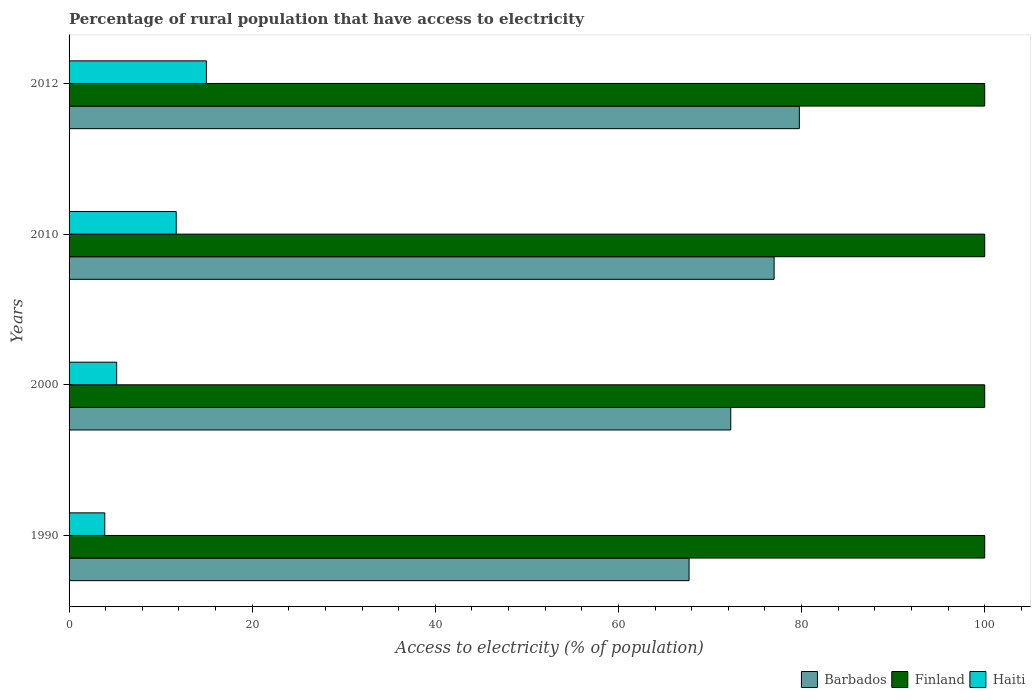How many bars are there on the 4th tick from the top?
Offer a terse response. 3. How many bars are there on the 3rd tick from the bottom?
Offer a very short reply. 3. What is the percentage of rural population that have access to electricity in Finland in 2000?
Offer a very short reply. 100. Across all years, what is the minimum percentage of rural population that have access to electricity in Barbados?
Keep it short and to the point. 67.71. In which year was the percentage of rural population that have access to electricity in Haiti maximum?
Ensure brevity in your answer.  2012. In which year was the percentage of rural population that have access to electricity in Barbados minimum?
Your answer should be compact. 1990. What is the total percentage of rural population that have access to electricity in Finland in the graph?
Your answer should be compact. 400. What is the difference between the percentage of rural population that have access to electricity in Barbados in 1990 and that in 2000?
Offer a very short reply. -4.55. What is the difference between the percentage of rural population that have access to electricity in Finland in 2000 and the percentage of rural population that have access to electricity in Barbados in 2012?
Offer a very short reply. 20.25. What is the average percentage of rural population that have access to electricity in Haiti per year?
Offer a very short reply. 8.95. In the year 2000, what is the difference between the percentage of rural population that have access to electricity in Haiti and percentage of rural population that have access to electricity in Barbados?
Ensure brevity in your answer.  -67.07. What is the ratio of the percentage of rural population that have access to electricity in Haiti in 2000 to that in 2012?
Ensure brevity in your answer.  0.35. What is the difference between the highest and the second highest percentage of rural population that have access to electricity in Haiti?
Provide a succinct answer. 3.3. Is the sum of the percentage of rural population that have access to electricity in Finland in 2000 and 2012 greater than the maximum percentage of rural population that have access to electricity in Haiti across all years?
Give a very brief answer. Yes. What does the 1st bar from the top in 2010 represents?
Provide a succinct answer. Haiti. What does the 3rd bar from the bottom in 2000 represents?
Your response must be concise. Haiti. Is it the case that in every year, the sum of the percentage of rural population that have access to electricity in Haiti and percentage of rural population that have access to electricity in Barbados is greater than the percentage of rural population that have access to electricity in Finland?
Ensure brevity in your answer.  No. How many bars are there?
Make the answer very short. 12. Are all the bars in the graph horizontal?
Ensure brevity in your answer.  Yes. How many years are there in the graph?
Offer a terse response. 4. What is the difference between two consecutive major ticks on the X-axis?
Provide a short and direct response. 20. Are the values on the major ticks of X-axis written in scientific E-notation?
Make the answer very short. No. Does the graph contain any zero values?
Make the answer very short. No. Does the graph contain grids?
Give a very brief answer. No. Where does the legend appear in the graph?
Offer a very short reply. Bottom right. How many legend labels are there?
Provide a succinct answer. 3. How are the legend labels stacked?
Give a very brief answer. Horizontal. What is the title of the graph?
Your answer should be compact. Percentage of rural population that have access to electricity. What is the label or title of the X-axis?
Your answer should be very brief. Access to electricity (% of population). What is the Access to electricity (% of population) in Barbados in 1990?
Your answer should be compact. 67.71. What is the Access to electricity (% of population) of Barbados in 2000?
Your response must be concise. 72.27. What is the Access to electricity (% of population) in Finland in 2000?
Give a very brief answer. 100. What is the Access to electricity (% of population) of Haiti in 2000?
Ensure brevity in your answer.  5.2. What is the Access to electricity (% of population) in Barbados in 2012?
Provide a succinct answer. 79.75. What is the Access to electricity (% of population) of Haiti in 2012?
Offer a very short reply. 15. Across all years, what is the maximum Access to electricity (% of population) in Barbados?
Provide a short and direct response. 79.75. Across all years, what is the maximum Access to electricity (% of population) of Haiti?
Keep it short and to the point. 15. Across all years, what is the minimum Access to electricity (% of population) of Barbados?
Your answer should be very brief. 67.71. What is the total Access to electricity (% of population) in Barbados in the graph?
Your response must be concise. 296.73. What is the total Access to electricity (% of population) in Haiti in the graph?
Keep it short and to the point. 35.8. What is the difference between the Access to electricity (% of population) of Barbados in 1990 and that in 2000?
Make the answer very short. -4.55. What is the difference between the Access to electricity (% of population) of Finland in 1990 and that in 2000?
Offer a very short reply. 0. What is the difference between the Access to electricity (% of population) of Haiti in 1990 and that in 2000?
Your answer should be compact. -1.3. What is the difference between the Access to electricity (% of population) of Barbados in 1990 and that in 2010?
Keep it short and to the point. -9.29. What is the difference between the Access to electricity (% of population) in Barbados in 1990 and that in 2012?
Offer a terse response. -12.04. What is the difference between the Access to electricity (% of population) of Finland in 1990 and that in 2012?
Your answer should be compact. 0. What is the difference between the Access to electricity (% of population) of Haiti in 1990 and that in 2012?
Provide a succinct answer. -11.1. What is the difference between the Access to electricity (% of population) of Barbados in 2000 and that in 2010?
Keep it short and to the point. -4.74. What is the difference between the Access to electricity (% of population) of Finland in 2000 and that in 2010?
Offer a very short reply. 0. What is the difference between the Access to electricity (% of population) in Haiti in 2000 and that in 2010?
Your response must be concise. -6.5. What is the difference between the Access to electricity (% of population) in Barbados in 2000 and that in 2012?
Your answer should be compact. -7.49. What is the difference between the Access to electricity (% of population) of Haiti in 2000 and that in 2012?
Ensure brevity in your answer.  -9.8. What is the difference between the Access to electricity (% of population) in Barbados in 2010 and that in 2012?
Your answer should be compact. -2.75. What is the difference between the Access to electricity (% of population) of Finland in 2010 and that in 2012?
Give a very brief answer. 0. What is the difference between the Access to electricity (% of population) of Haiti in 2010 and that in 2012?
Offer a very short reply. -3.3. What is the difference between the Access to electricity (% of population) of Barbados in 1990 and the Access to electricity (% of population) of Finland in 2000?
Ensure brevity in your answer.  -32.29. What is the difference between the Access to electricity (% of population) in Barbados in 1990 and the Access to electricity (% of population) in Haiti in 2000?
Ensure brevity in your answer.  62.51. What is the difference between the Access to electricity (% of population) of Finland in 1990 and the Access to electricity (% of population) of Haiti in 2000?
Give a very brief answer. 94.8. What is the difference between the Access to electricity (% of population) of Barbados in 1990 and the Access to electricity (% of population) of Finland in 2010?
Offer a terse response. -32.29. What is the difference between the Access to electricity (% of population) in Barbados in 1990 and the Access to electricity (% of population) in Haiti in 2010?
Your answer should be compact. 56.01. What is the difference between the Access to electricity (% of population) in Finland in 1990 and the Access to electricity (% of population) in Haiti in 2010?
Provide a succinct answer. 88.3. What is the difference between the Access to electricity (% of population) of Barbados in 1990 and the Access to electricity (% of population) of Finland in 2012?
Your answer should be compact. -32.29. What is the difference between the Access to electricity (% of population) of Barbados in 1990 and the Access to electricity (% of population) of Haiti in 2012?
Ensure brevity in your answer.  52.71. What is the difference between the Access to electricity (% of population) of Finland in 1990 and the Access to electricity (% of population) of Haiti in 2012?
Give a very brief answer. 85. What is the difference between the Access to electricity (% of population) in Barbados in 2000 and the Access to electricity (% of population) in Finland in 2010?
Your response must be concise. -27.73. What is the difference between the Access to electricity (% of population) in Barbados in 2000 and the Access to electricity (% of population) in Haiti in 2010?
Provide a short and direct response. 60.56. What is the difference between the Access to electricity (% of population) in Finland in 2000 and the Access to electricity (% of population) in Haiti in 2010?
Provide a succinct answer. 88.3. What is the difference between the Access to electricity (% of population) of Barbados in 2000 and the Access to electricity (% of population) of Finland in 2012?
Offer a very short reply. -27.73. What is the difference between the Access to electricity (% of population) in Barbados in 2000 and the Access to electricity (% of population) in Haiti in 2012?
Offer a terse response. 57.27. What is the difference between the Access to electricity (% of population) in Finland in 2000 and the Access to electricity (% of population) in Haiti in 2012?
Make the answer very short. 85. What is the difference between the Access to electricity (% of population) in Barbados in 2010 and the Access to electricity (% of population) in Haiti in 2012?
Offer a terse response. 62. What is the difference between the Access to electricity (% of population) of Finland in 2010 and the Access to electricity (% of population) of Haiti in 2012?
Give a very brief answer. 85. What is the average Access to electricity (% of population) of Barbados per year?
Offer a terse response. 74.18. What is the average Access to electricity (% of population) in Haiti per year?
Your answer should be compact. 8.95. In the year 1990, what is the difference between the Access to electricity (% of population) in Barbados and Access to electricity (% of population) in Finland?
Give a very brief answer. -32.29. In the year 1990, what is the difference between the Access to electricity (% of population) in Barbados and Access to electricity (% of population) in Haiti?
Your answer should be compact. 63.81. In the year 1990, what is the difference between the Access to electricity (% of population) of Finland and Access to electricity (% of population) of Haiti?
Provide a short and direct response. 96.1. In the year 2000, what is the difference between the Access to electricity (% of population) of Barbados and Access to electricity (% of population) of Finland?
Provide a short and direct response. -27.73. In the year 2000, what is the difference between the Access to electricity (% of population) in Barbados and Access to electricity (% of population) in Haiti?
Offer a very short reply. 67.06. In the year 2000, what is the difference between the Access to electricity (% of population) of Finland and Access to electricity (% of population) of Haiti?
Provide a succinct answer. 94.8. In the year 2010, what is the difference between the Access to electricity (% of population) of Barbados and Access to electricity (% of population) of Finland?
Make the answer very short. -23. In the year 2010, what is the difference between the Access to electricity (% of population) in Barbados and Access to electricity (% of population) in Haiti?
Provide a short and direct response. 65.3. In the year 2010, what is the difference between the Access to electricity (% of population) in Finland and Access to electricity (% of population) in Haiti?
Ensure brevity in your answer.  88.3. In the year 2012, what is the difference between the Access to electricity (% of population) of Barbados and Access to electricity (% of population) of Finland?
Make the answer very short. -20.25. In the year 2012, what is the difference between the Access to electricity (% of population) of Barbados and Access to electricity (% of population) of Haiti?
Your answer should be compact. 64.75. What is the ratio of the Access to electricity (% of population) of Barbados in 1990 to that in 2000?
Offer a very short reply. 0.94. What is the ratio of the Access to electricity (% of population) in Finland in 1990 to that in 2000?
Offer a terse response. 1. What is the ratio of the Access to electricity (% of population) in Barbados in 1990 to that in 2010?
Your response must be concise. 0.88. What is the ratio of the Access to electricity (% of population) in Finland in 1990 to that in 2010?
Offer a very short reply. 1. What is the ratio of the Access to electricity (% of population) in Haiti in 1990 to that in 2010?
Provide a short and direct response. 0.33. What is the ratio of the Access to electricity (% of population) of Barbados in 1990 to that in 2012?
Your response must be concise. 0.85. What is the ratio of the Access to electricity (% of population) of Haiti in 1990 to that in 2012?
Provide a succinct answer. 0.26. What is the ratio of the Access to electricity (% of population) in Barbados in 2000 to that in 2010?
Offer a very short reply. 0.94. What is the ratio of the Access to electricity (% of population) of Finland in 2000 to that in 2010?
Provide a short and direct response. 1. What is the ratio of the Access to electricity (% of population) of Haiti in 2000 to that in 2010?
Make the answer very short. 0.44. What is the ratio of the Access to electricity (% of population) in Barbados in 2000 to that in 2012?
Your response must be concise. 0.91. What is the ratio of the Access to electricity (% of population) of Haiti in 2000 to that in 2012?
Your answer should be very brief. 0.35. What is the ratio of the Access to electricity (% of population) in Barbados in 2010 to that in 2012?
Offer a terse response. 0.97. What is the ratio of the Access to electricity (% of population) in Finland in 2010 to that in 2012?
Provide a succinct answer. 1. What is the ratio of the Access to electricity (% of population) in Haiti in 2010 to that in 2012?
Your answer should be compact. 0.78. What is the difference between the highest and the second highest Access to electricity (% of population) of Barbados?
Offer a very short reply. 2.75. What is the difference between the highest and the second highest Access to electricity (% of population) of Finland?
Make the answer very short. 0. What is the difference between the highest and the second highest Access to electricity (% of population) of Haiti?
Give a very brief answer. 3.3. What is the difference between the highest and the lowest Access to electricity (% of population) in Barbados?
Offer a very short reply. 12.04. What is the difference between the highest and the lowest Access to electricity (% of population) of Finland?
Your response must be concise. 0. What is the difference between the highest and the lowest Access to electricity (% of population) of Haiti?
Provide a succinct answer. 11.1. 